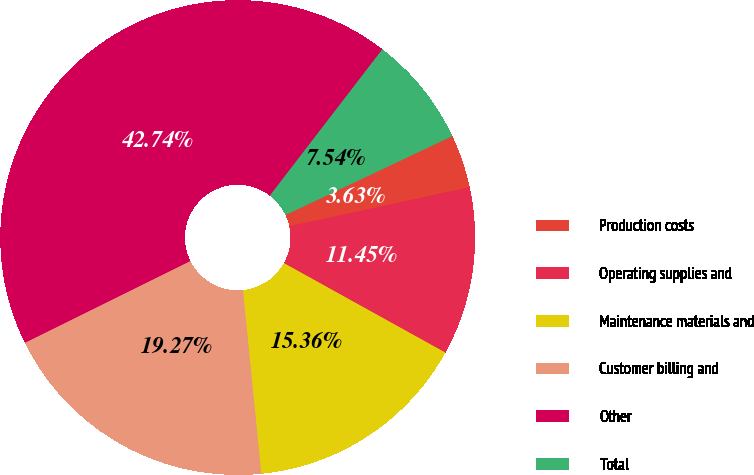Convert chart to OTSL. <chart><loc_0><loc_0><loc_500><loc_500><pie_chart><fcel>Production costs<fcel>Operating supplies and<fcel>Maintenance materials and<fcel>Customer billing and<fcel>Other<fcel>Total<nl><fcel>3.63%<fcel>11.45%<fcel>15.36%<fcel>19.27%<fcel>42.73%<fcel>7.54%<nl></chart> 